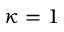<formula> <loc_0><loc_0><loc_500><loc_500>\kappa = 1</formula> 